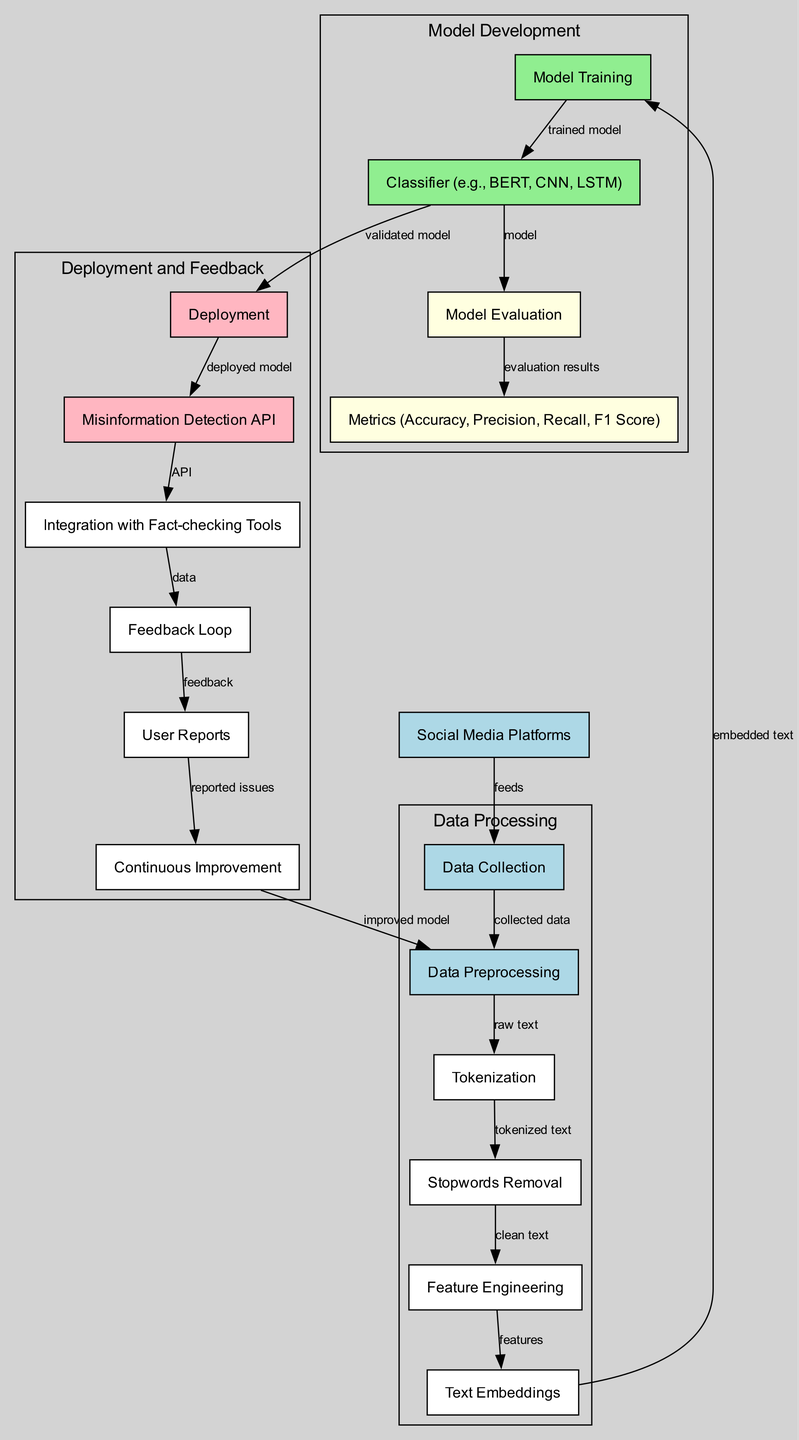What are the sources of data collection? The node labeled "Data Sources" indicates that data is collected from "Social Media Platforms." This is shown as a connection that feeds into the "Data Collection" node.
Answer: Social Media Platforms What follows after data preprocessing? After the node labeled "Data Preprocessing," the next stage in the workflow is indicated by the arrow leading to the "Tokenization" node. This demonstrates the sequential flow where tokenization occurs after preprocessing.
Answer: Tokenization How many evaluation metrics are shown in the diagram? The "Metrics" node displays multiple evaluation metrics including accuracy, precision, recall, and F1 score. Since these metrics are explicitly listed, counting them gives us a total of four metrics.
Answer: Four What is the purpose of the feedback loop? The "Feedback Loop" is connected to "User Reports," indicating that it collects information from users about reported issues. This feedback aids in the "Continuous Improvement" process, creating an iterative mechanism for enhancing the model.
Answer: Continuous Improvement Which node is responsible for deploying the model? The "Deployment" node is identified as the phase where the model is made operational, connecting to the "Misinformation Detection API" node. Hence, this node represents the deployment aspect of the workflow.
Answer: Deployment What connections exist between model training and classifier choices? The arrow from "Model Training" to "Classifier (e.g., BERT, CNN, LSTM)" indicates that the trained model is a precursor to deciding upon the specific classification algorithm to use, suggesting a dependency in this workflow step.
Answer: Trained model What does the integration with fact-checking tools achieve? The "Integration with Fact-checking Tools" node highlights that it utilizes data from the "Misinformation Detection API," indicating a collaboration to leverage fact-checking resources to combat misinformation effectively.
Answer: Data Which node indicates the beginning of data processing? The "Data Collection" node signifies the starting point of data processing. It receives input from the "Social Media Platforms" node, which represents where the data originates.
Answer: Data Collection How does user feedback contribute to the flow? User feedback collected through "User Reports" feeds back into the "Continuous Improvement" node, illustrating how insights from users help refine and improve the overall model in a cyclical manner.
Answer: Continuous Improvement 